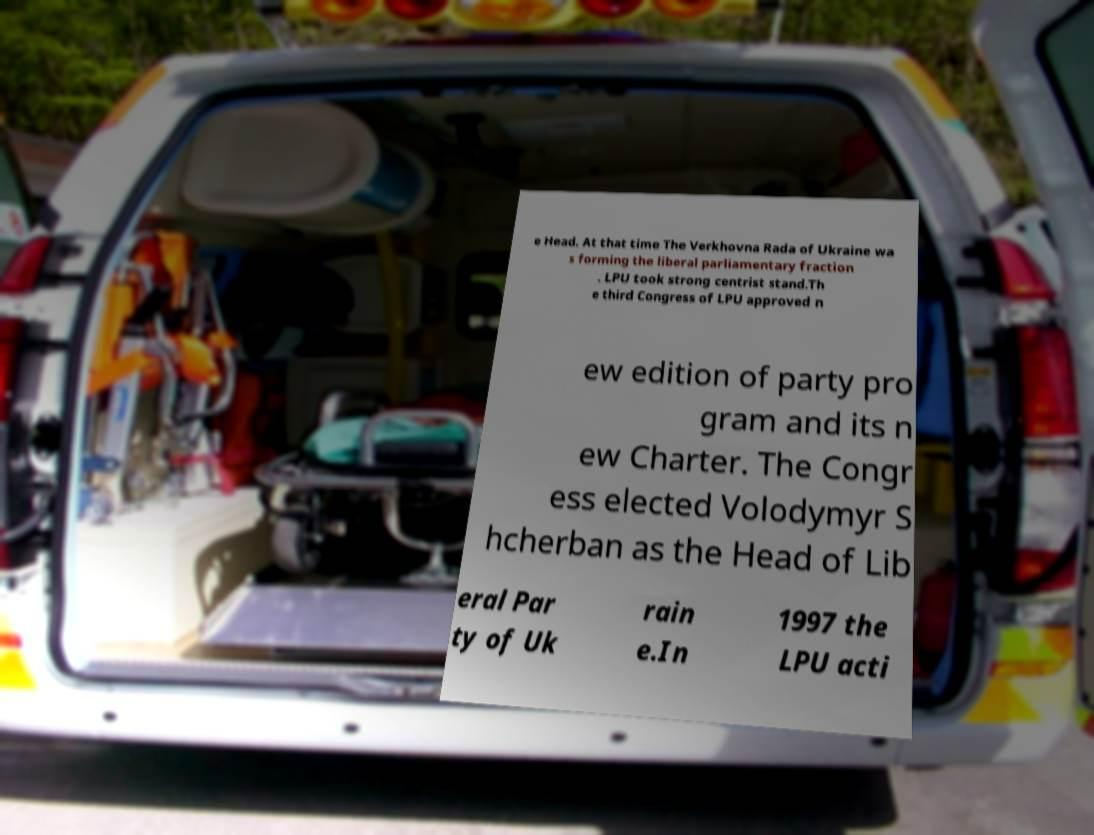Can you accurately transcribe the text from the provided image for me? e Head. At that time The Verkhovna Rada of Ukraine wa s forming the liberal parliamentary fraction . LPU took strong centrist stand.Th e third Congress of LPU approved n ew edition of party pro gram and its n ew Charter. The Congr ess elected Volodymyr S hcherban as the Head of Lib eral Par ty of Uk rain e.In 1997 the LPU acti 